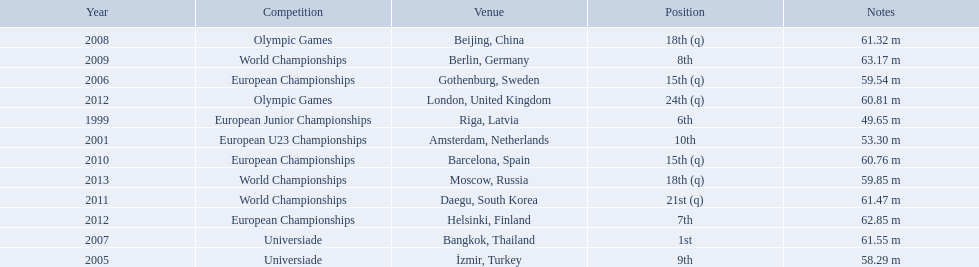Which competitions has gerhard mayer competed in since 1999? European Junior Championships, European U23 Championships, Universiade, European Championships, Universiade, Olympic Games, World Championships, European Championships, World Championships, European Championships, Olympic Games, World Championships. Of these competition, in which ones did he throw at least 60 m? Universiade, Olympic Games, World Championships, European Championships, World Championships, European Championships, Olympic Games. Of these throws, which was his longest? 63.17 m. What were the distances of mayer's throws? 49.65 m, 53.30 m, 58.29 m, 59.54 m, 61.55 m, 61.32 m, 63.17 m, 60.76 m, 61.47 m, 62.85 m, 60.81 m, 59.85 m. Which of these went the farthest? 63.17 m. 